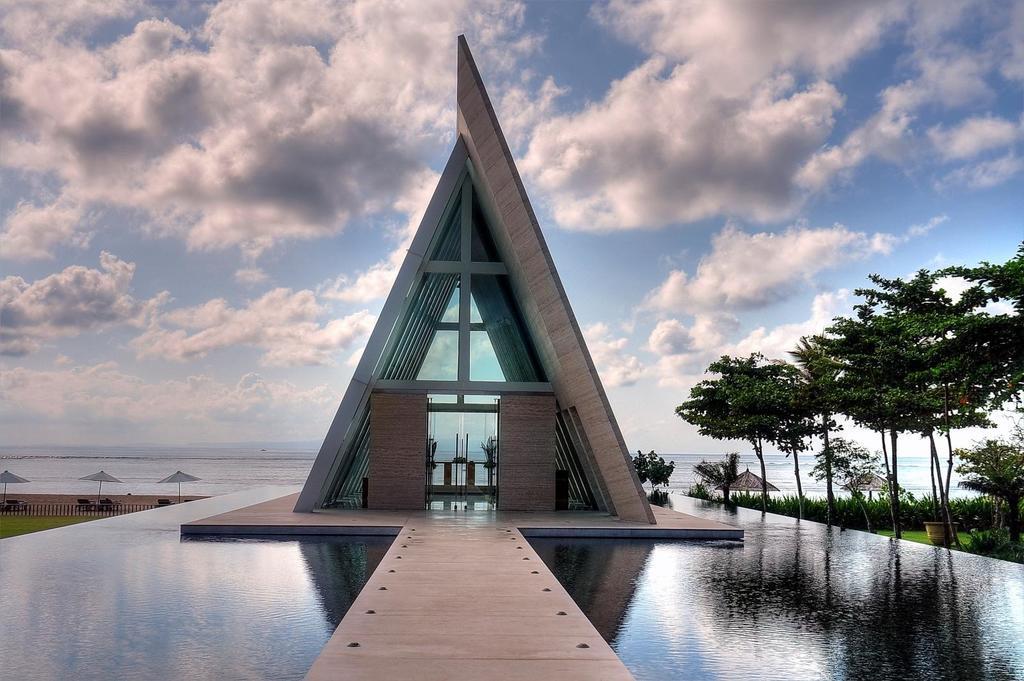Could you give a brief overview of what you see in this image? In this picture we can see the path, water, building, trees, umbrellas, fence, plants, some objects and in the background we can see the sky with clouds. 